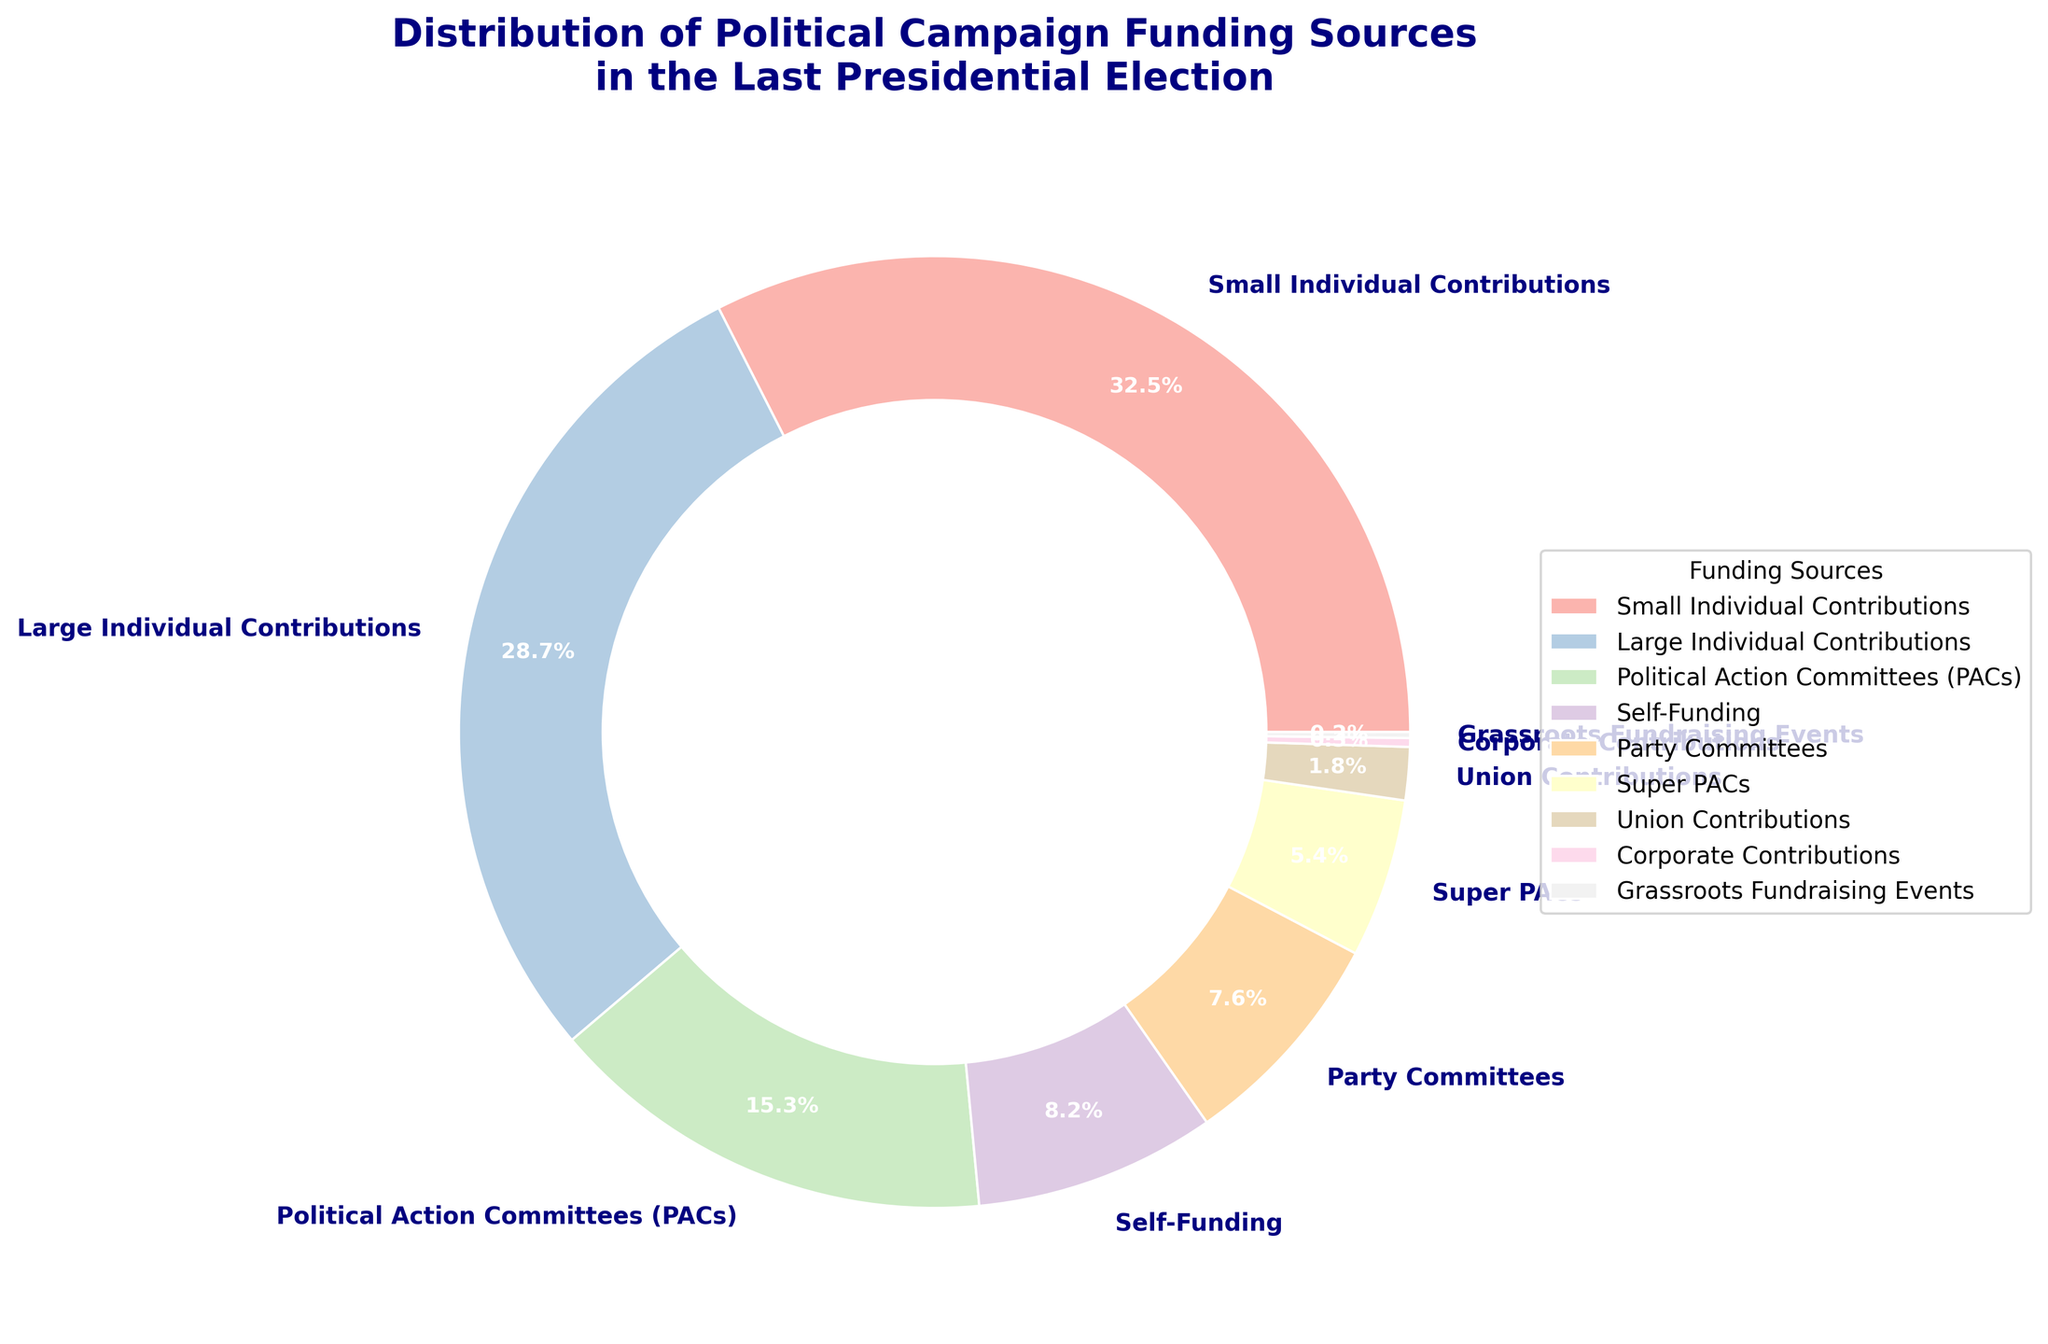Which funding source contributed the largest percentage to the campaign? From the pie chart, the largest segment with 32.5% is labeled "Small Individual Contributions", indicating that it is the largest funding source.
Answer: Small Individual Contributions Which funding source has a larger percentage: Super PACs or Party Committees? Comparing the segments, Super PACs contributed 5.4%, while Party Committees contributed 7.6%. Therefore, Party Committees have a larger percentage.
Answer: Party Committees What is the total percentage of contributions from individual sources (both small and large)? Adding the percentages of Small Individual Contributions (32.5%) and Large Individual Contributions (28.7%) gives a total of 32.5 + 28.7 = 61.2%.
Answer: 61.2% How does the contribution from Union Contributions compare to Corporate Contributions? Union Contributions are 1.8%, whereas Corporate Contributions are 0.3%. Therefore, Union Contributions are greater than Corporate Contributions.
Answer: Union Contributions are greater What percentage more do Self-Funding and Grassroots Fundraising Events contribute combined compared to Union Contributions alone? Adding Self-Funding (8.2%) and Grassroots Fundraising Events (0.2%) gives 8.4%. Subtracting Union Contributions (1.8%) from the combined amount gives 8.4 - 1.8 = 6.6%.
Answer: 6.6% Which funding source is represented by the smallest segment? The smallest segment corresponds to Grassroots Fundraising Events with 0.2%.
Answer: Grassroots Fundraising Events Are contributions from Self-Funding higher or lower than those from Political Action Committees (PACs)? Contributions from Self-Funding are 8.2%, whereas Political Action Committees (PACs) contribute 15.3%, so Self-Funding is lower.
Answer: Lower What is the sum of contributions from sources other than individual or union contributions, Self-Funding, and Political Action Committees? Adding Party Committees (7.6%), Super PACs (5.4%), Corporate Contributions (0.3%), and Grassroots Fundraising Events (0.2%) results in 13.5%.
Answer: 13.5% What is the difference in percentage between the contributions from Party Committees and Super PACs? Party Committees contribute 7.6%, and Super PACs contribute 5.4%. The difference is 7.6 - 5.4 = 2.2%.
Answer: 2.2% 